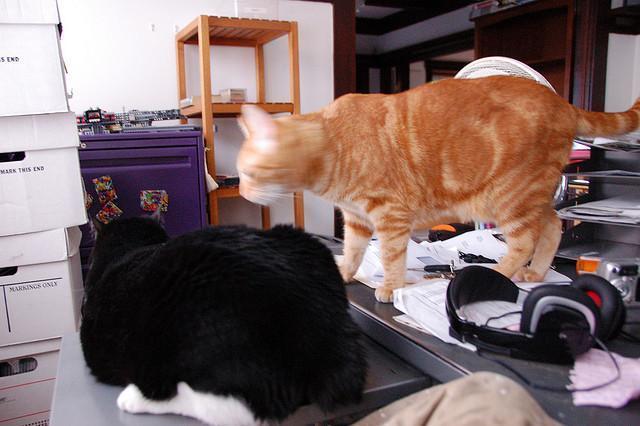How many boxes are stacked on top of one another?
Give a very brief answer. 4. How many cats are there?
Give a very brief answer. 2. 